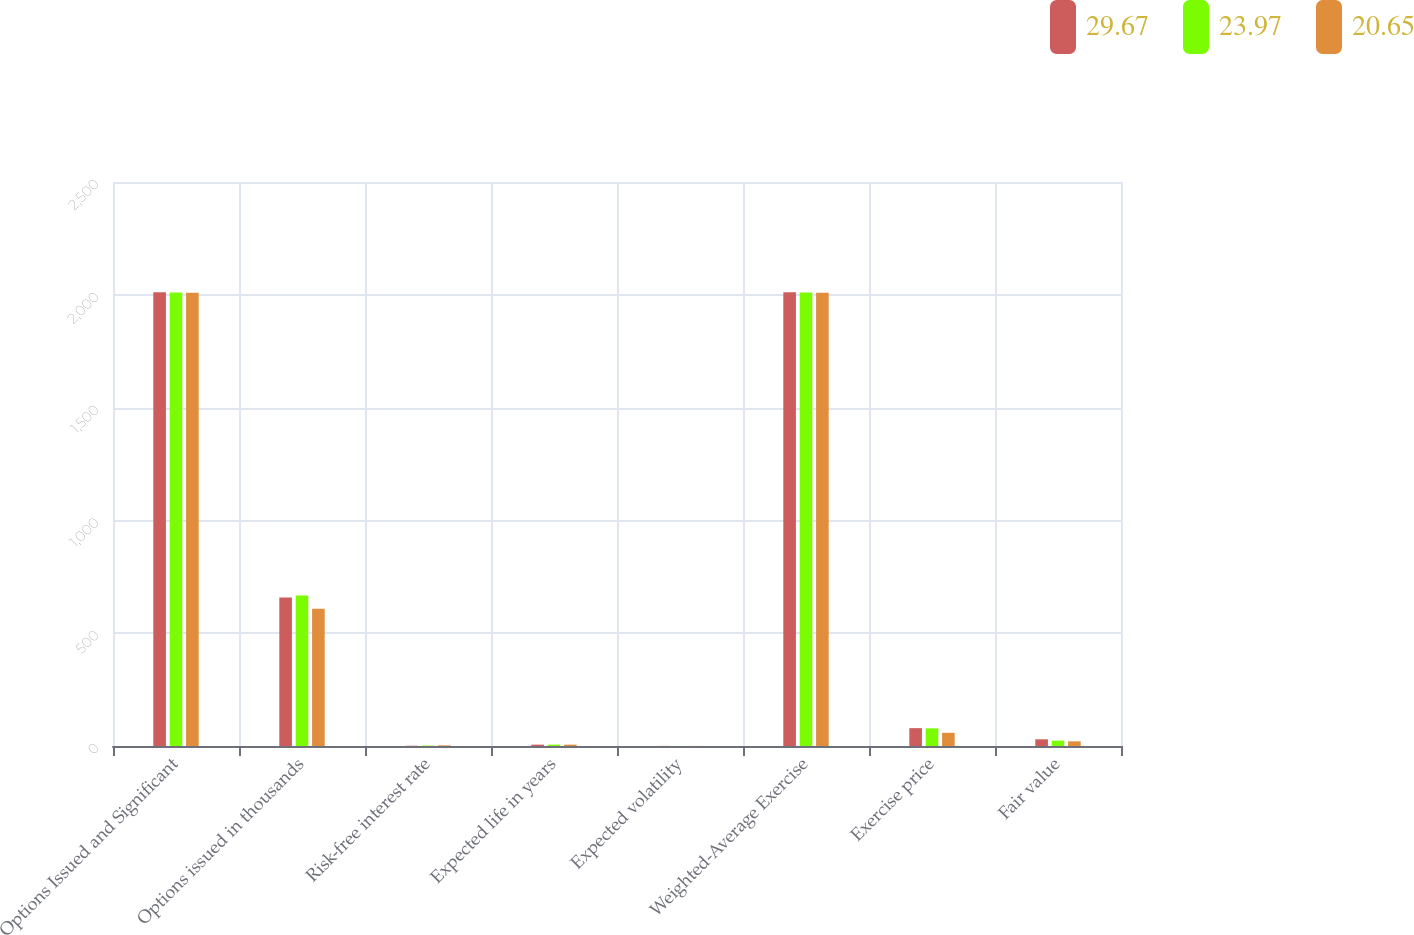Convert chart. <chart><loc_0><loc_0><loc_500><loc_500><stacked_bar_chart><ecel><fcel>Options Issued and Significant<fcel>Options issued in thousands<fcel>Risk-free interest rate<fcel>Expected life in years<fcel>Expected volatility<fcel>Weighted-Average Exercise<fcel>Exercise price<fcel>Fair value<nl><fcel>29.67<fcel>2011<fcel>658<fcel>1.1<fcel>6<fcel>0.38<fcel>2011<fcel>79.1<fcel>29.67<nl><fcel>23.97<fcel>2010<fcel>667<fcel>2<fcel>6<fcel>0.27<fcel>2010<fcel>78.21<fcel>23.97<nl><fcel>20.65<fcel>2009<fcel>608<fcel>2.9<fcel>6<fcel>0.3<fcel>2009<fcel>58.46<fcel>20.65<nl></chart> 